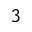<formula> <loc_0><loc_0><loc_500><loc_500>^ { 3 }</formula> 